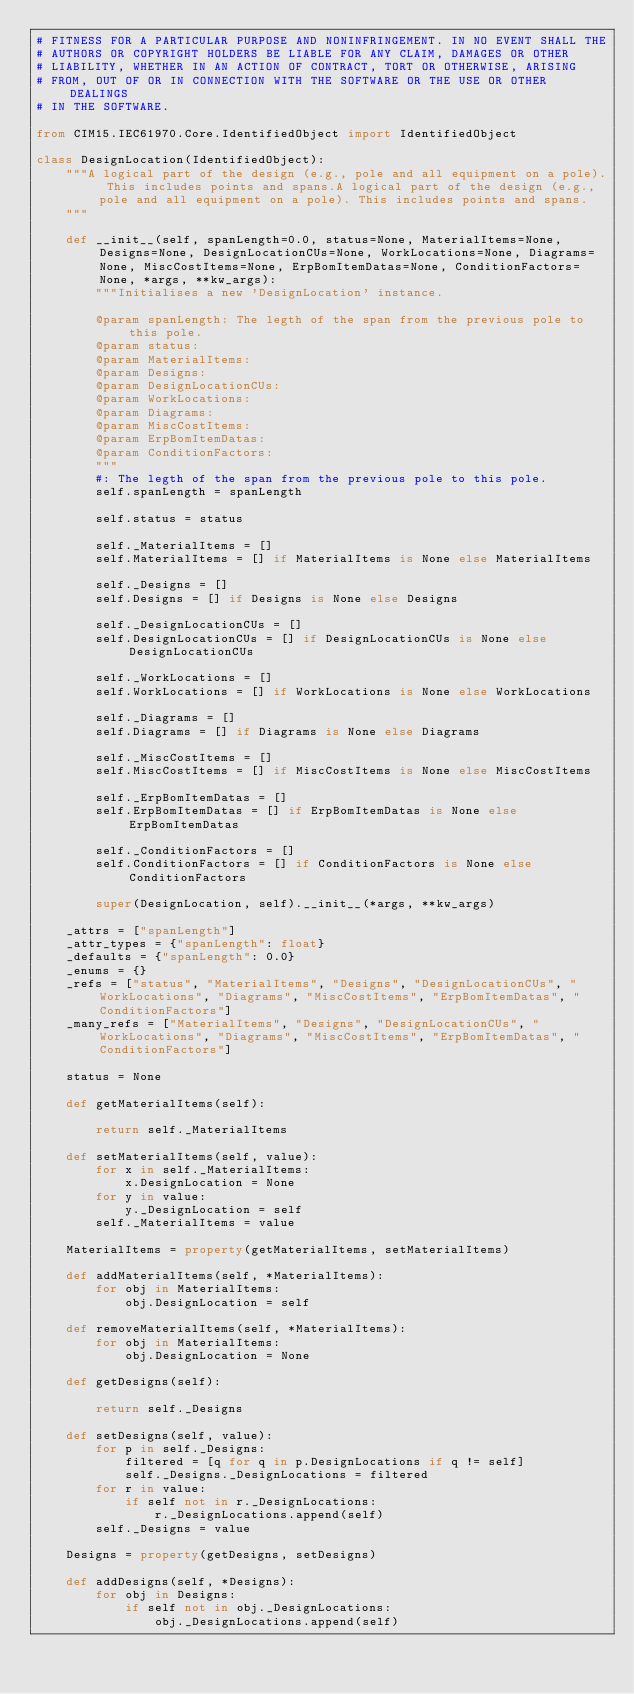Convert code to text. <code><loc_0><loc_0><loc_500><loc_500><_Python_># FITNESS FOR A PARTICULAR PURPOSE AND NONINFRINGEMENT. IN NO EVENT SHALL THE
# AUTHORS OR COPYRIGHT HOLDERS BE LIABLE FOR ANY CLAIM, DAMAGES OR OTHER
# LIABILITY, WHETHER IN AN ACTION OF CONTRACT, TORT OR OTHERWISE, ARISING
# FROM, OUT OF OR IN CONNECTION WITH THE SOFTWARE OR THE USE OR OTHER DEALINGS
# IN THE SOFTWARE.

from CIM15.IEC61970.Core.IdentifiedObject import IdentifiedObject

class DesignLocation(IdentifiedObject):
    """A logical part of the design (e.g., pole and all equipment on a pole). This includes points and spans.A logical part of the design (e.g., pole and all equipment on a pole). This includes points and spans.
    """

    def __init__(self, spanLength=0.0, status=None, MaterialItems=None, Designs=None, DesignLocationCUs=None, WorkLocations=None, Diagrams=None, MiscCostItems=None, ErpBomItemDatas=None, ConditionFactors=None, *args, **kw_args):
        """Initialises a new 'DesignLocation' instance.

        @param spanLength: The legth of the span from the previous pole to this pole. 
        @param status:
        @param MaterialItems:
        @param Designs:
        @param DesignLocationCUs:
        @param WorkLocations:
        @param Diagrams:
        @param MiscCostItems:
        @param ErpBomItemDatas:
        @param ConditionFactors:
        """
        #: The legth of the span from the previous pole to this pole.
        self.spanLength = spanLength

        self.status = status

        self._MaterialItems = []
        self.MaterialItems = [] if MaterialItems is None else MaterialItems

        self._Designs = []
        self.Designs = [] if Designs is None else Designs

        self._DesignLocationCUs = []
        self.DesignLocationCUs = [] if DesignLocationCUs is None else DesignLocationCUs

        self._WorkLocations = []
        self.WorkLocations = [] if WorkLocations is None else WorkLocations

        self._Diagrams = []
        self.Diagrams = [] if Diagrams is None else Diagrams

        self._MiscCostItems = []
        self.MiscCostItems = [] if MiscCostItems is None else MiscCostItems

        self._ErpBomItemDatas = []
        self.ErpBomItemDatas = [] if ErpBomItemDatas is None else ErpBomItemDatas

        self._ConditionFactors = []
        self.ConditionFactors = [] if ConditionFactors is None else ConditionFactors

        super(DesignLocation, self).__init__(*args, **kw_args)

    _attrs = ["spanLength"]
    _attr_types = {"spanLength": float}
    _defaults = {"spanLength": 0.0}
    _enums = {}
    _refs = ["status", "MaterialItems", "Designs", "DesignLocationCUs", "WorkLocations", "Diagrams", "MiscCostItems", "ErpBomItemDatas", "ConditionFactors"]
    _many_refs = ["MaterialItems", "Designs", "DesignLocationCUs", "WorkLocations", "Diagrams", "MiscCostItems", "ErpBomItemDatas", "ConditionFactors"]

    status = None

    def getMaterialItems(self):
        
        return self._MaterialItems

    def setMaterialItems(self, value):
        for x in self._MaterialItems:
            x.DesignLocation = None
        for y in value:
            y._DesignLocation = self
        self._MaterialItems = value

    MaterialItems = property(getMaterialItems, setMaterialItems)

    def addMaterialItems(self, *MaterialItems):
        for obj in MaterialItems:
            obj.DesignLocation = self

    def removeMaterialItems(self, *MaterialItems):
        for obj in MaterialItems:
            obj.DesignLocation = None

    def getDesigns(self):
        
        return self._Designs

    def setDesigns(self, value):
        for p in self._Designs:
            filtered = [q for q in p.DesignLocations if q != self]
            self._Designs._DesignLocations = filtered
        for r in value:
            if self not in r._DesignLocations:
                r._DesignLocations.append(self)
        self._Designs = value

    Designs = property(getDesigns, setDesigns)

    def addDesigns(self, *Designs):
        for obj in Designs:
            if self not in obj._DesignLocations:
                obj._DesignLocations.append(self)</code> 